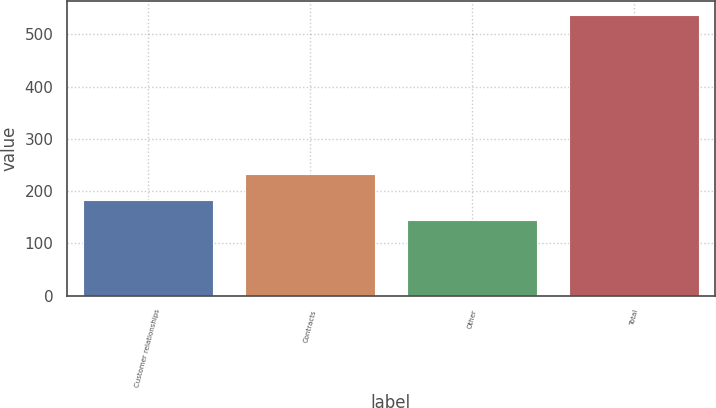Convert chart. <chart><loc_0><loc_0><loc_500><loc_500><bar_chart><fcel>Customer relationships<fcel>Contracts<fcel>Other<fcel>Total<nl><fcel>183.2<fcel>233<fcel>144<fcel>536<nl></chart> 